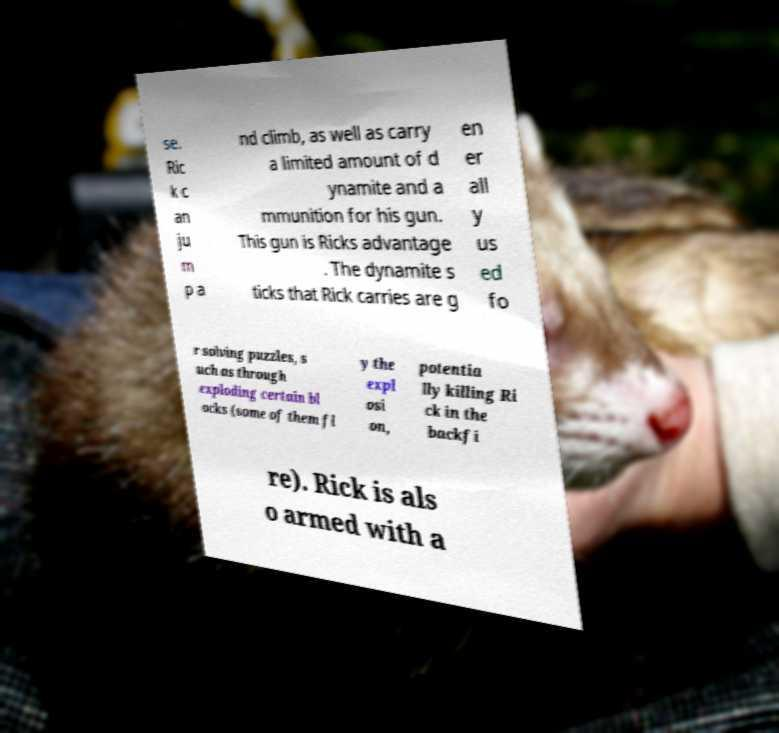I need the written content from this picture converted into text. Can you do that? se. Ric k c an ju m p a nd climb, as well as carry a limited amount of d ynamite and a mmunition for his gun. This gun is Ricks advantage . The dynamite s ticks that Rick carries are g en er all y us ed fo r solving puzzles, s uch as through exploding certain bl ocks (some of them fl y the expl osi on, potentia lly killing Ri ck in the backfi re). Rick is als o armed with a 